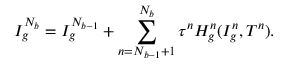Convert formula to latex. <formula><loc_0><loc_0><loc_500><loc_500>I _ { g } ^ { N _ { b } } = I _ { g } ^ { N _ { b - 1 } } + \sum _ { n = N _ { b - 1 } + 1 } ^ { N _ { b } } \tau ^ { n } H _ { g } ^ { n } ( I _ { g } ^ { n } , T ^ { n } ) .</formula> 